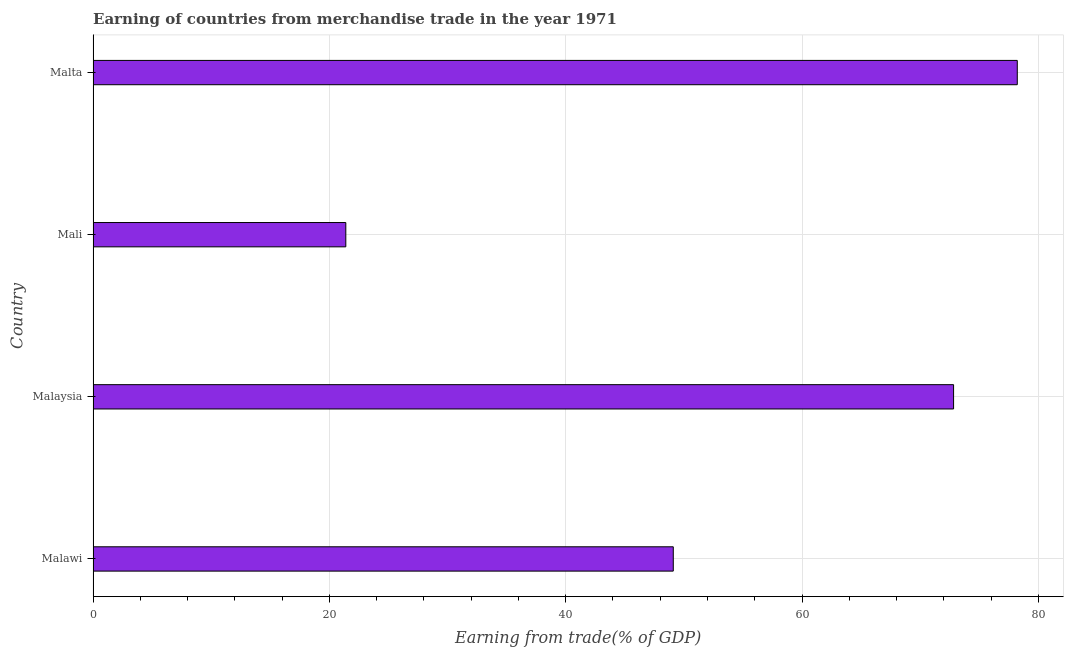What is the title of the graph?
Your response must be concise. Earning of countries from merchandise trade in the year 1971. What is the label or title of the X-axis?
Provide a succinct answer. Earning from trade(% of GDP). What is the label or title of the Y-axis?
Ensure brevity in your answer.  Country. What is the earning from merchandise trade in Malaysia?
Ensure brevity in your answer.  72.83. Across all countries, what is the maximum earning from merchandise trade?
Give a very brief answer. 78.22. Across all countries, what is the minimum earning from merchandise trade?
Keep it short and to the point. 21.39. In which country was the earning from merchandise trade maximum?
Provide a short and direct response. Malta. In which country was the earning from merchandise trade minimum?
Provide a short and direct response. Mali. What is the sum of the earning from merchandise trade?
Offer a terse response. 221.54. What is the difference between the earning from merchandise trade in Malawi and Mali?
Provide a short and direct response. 27.71. What is the average earning from merchandise trade per country?
Give a very brief answer. 55.39. What is the median earning from merchandise trade?
Your answer should be compact. 60.97. What is the ratio of the earning from merchandise trade in Mali to that in Malta?
Offer a terse response. 0.27. What is the difference between the highest and the second highest earning from merchandise trade?
Give a very brief answer. 5.39. Is the sum of the earning from merchandise trade in Malawi and Mali greater than the maximum earning from merchandise trade across all countries?
Your answer should be very brief. No. What is the difference between the highest and the lowest earning from merchandise trade?
Provide a succinct answer. 56.83. Are all the bars in the graph horizontal?
Your response must be concise. Yes. What is the Earning from trade(% of GDP) in Malawi?
Your answer should be compact. 49.1. What is the Earning from trade(% of GDP) in Malaysia?
Make the answer very short. 72.83. What is the Earning from trade(% of GDP) of Mali?
Provide a short and direct response. 21.39. What is the Earning from trade(% of GDP) in Malta?
Give a very brief answer. 78.22. What is the difference between the Earning from trade(% of GDP) in Malawi and Malaysia?
Offer a terse response. -23.72. What is the difference between the Earning from trade(% of GDP) in Malawi and Mali?
Give a very brief answer. 27.71. What is the difference between the Earning from trade(% of GDP) in Malawi and Malta?
Offer a very short reply. -29.12. What is the difference between the Earning from trade(% of GDP) in Malaysia and Mali?
Offer a very short reply. 51.44. What is the difference between the Earning from trade(% of GDP) in Malaysia and Malta?
Make the answer very short. -5.39. What is the difference between the Earning from trade(% of GDP) in Mali and Malta?
Give a very brief answer. -56.83. What is the ratio of the Earning from trade(% of GDP) in Malawi to that in Malaysia?
Offer a very short reply. 0.67. What is the ratio of the Earning from trade(% of GDP) in Malawi to that in Mali?
Provide a succinct answer. 2.3. What is the ratio of the Earning from trade(% of GDP) in Malawi to that in Malta?
Provide a short and direct response. 0.63. What is the ratio of the Earning from trade(% of GDP) in Malaysia to that in Mali?
Offer a very short reply. 3.4. What is the ratio of the Earning from trade(% of GDP) in Malaysia to that in Malta?
Provide a short and direct response. 0.93. What is the ratio of the Earning from trade(% of GDP) in Mali to that in Malta?
Your answer should be compact. 0.27. 